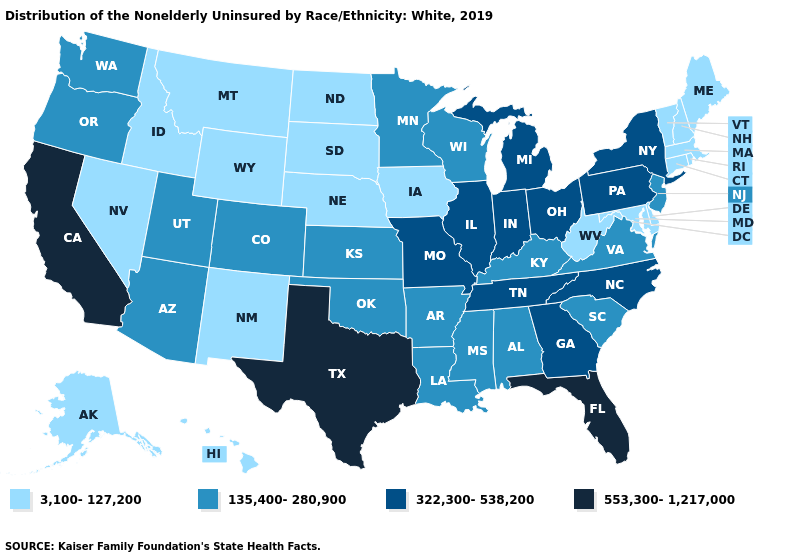Name the states that have a value in the range 3,100-127,200?
Answer briefly. Alaska, Connecticut, Delaware, Hawaii, Idaho, Iowa, Maine, Maryland, Massachusetts, Montana, Nebraska, Nevada, New Hampshire, New Mexico, North Dakota, Rhode Island, South Dakota, Vermont, West Virginia, Wyoming. Which states have the lowest value in the USA?
Short answer required. Alaska, Connecticut, Delaware, Hawaii, Idaho, Iowa, Maine, Maryland, Massachusetts, Montana, Nebraska, Nevada, New Hampshire, New Mexico, North Dakota, Rhode Island, South Dakota, Vermont, West Virginia, Wyoming. What is the value of Alaska?
Keep it brief. 3,100-127,200. What is the value of Tennessee?
Answer briefly. 322,300-538,200. What is the value of New Mexico?
Answer briefly. 3,100-127,200. Which states have the highest value in the USA?
Concise answer only. California, Florida, Texas. What is the highest value in the USA?
Keep it brief. 553,300-1,217,000. Which states have the highest value in the USA?
Keep it brief. California, Florida, Texas. Does North Carolina have the same value as North Dakota?
Concise answer only. No. Among the states that border Nebraska , does Iowa have the highest value?
Short answer required. No. Name the states that have a value in the range 553,300-1,217,000?
Answer briefly. California, Florida, Texas. Among the states that border South Carolina , which have the highest value?
Short answer required. Georgia, North Carolina. What is the value of Ohio?
Write a very short answer. 322,300-538,200. Does California have the lowest value in the West?
Short answer required. No. What is the value of Wyoming?
Concise answer only. 3,100-127,200. 